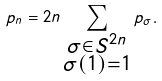Convert formula to latex. <formula><loc_0><loc_0><loc_500><loc_500>p _ { n } = 2 n \sum _ { \substack { \sigma \in S ^ { 2 n } \\ \sigma ( 1 ) = 1 } } p _ { \sigma } .</formula> 